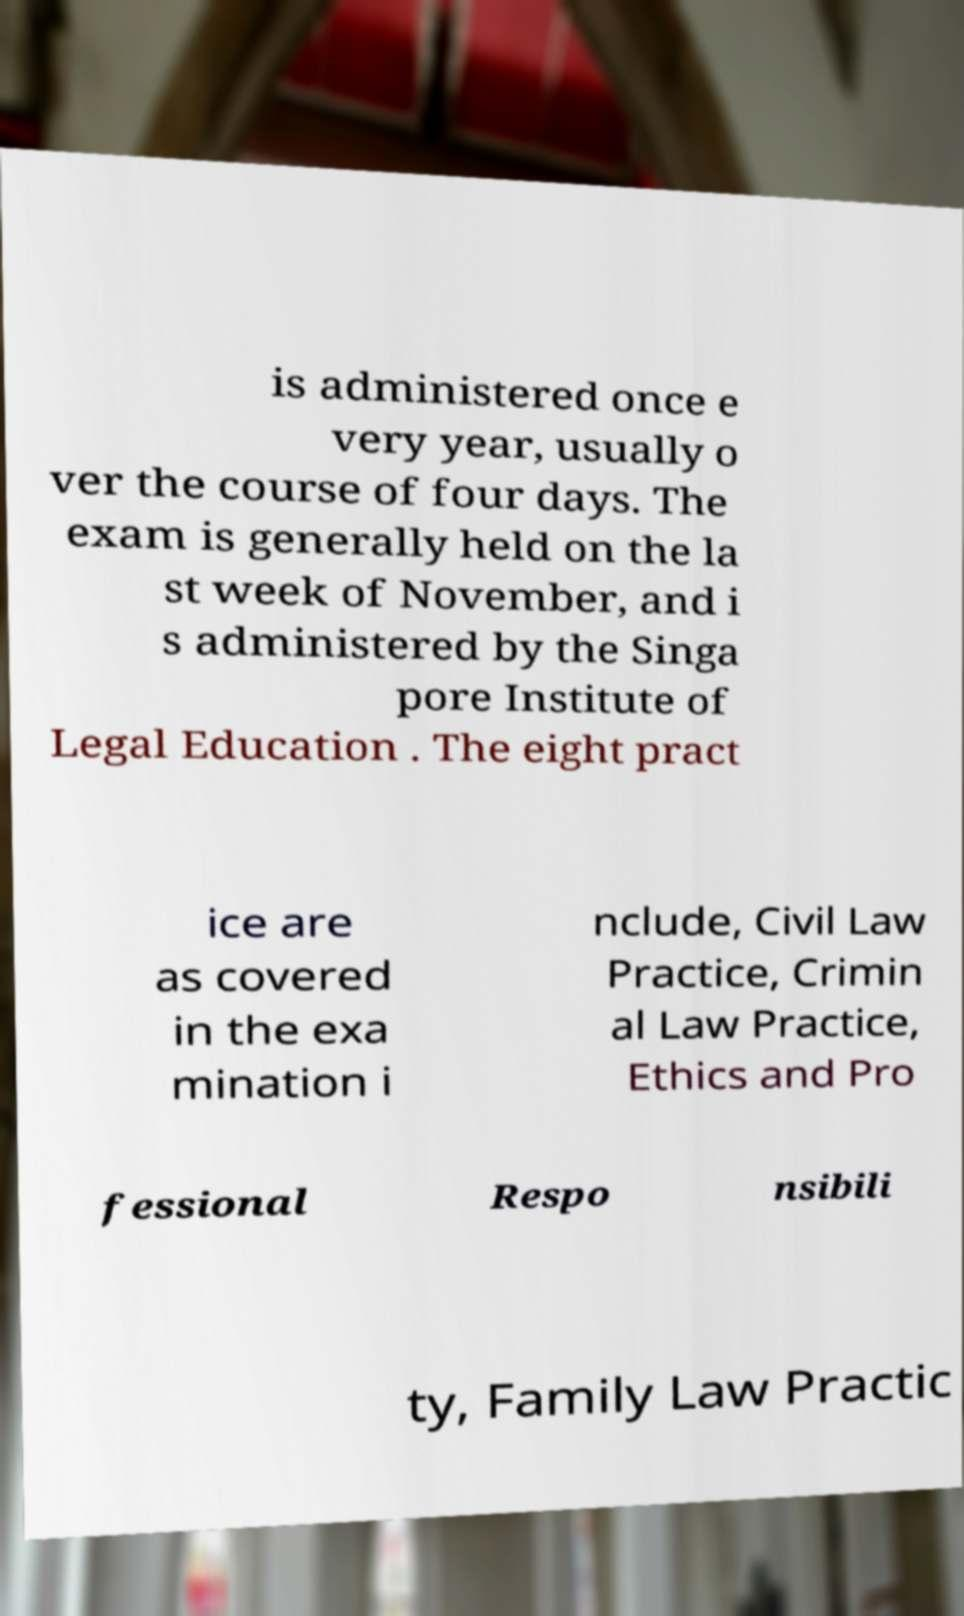Please identify and transcribe the text found in this image. is administered once e very year, usually o ver the course of four days. The exam is generally held on the la st week of November, and i s administered by the Singa pore Institute of Legal Education . The eight pract ice are as covered in the exa mination i nclude, Civil Law Practice, Crimin al Law Practice, Ethics and Pro fessional Respo nsibili ty, Family Law Practic 